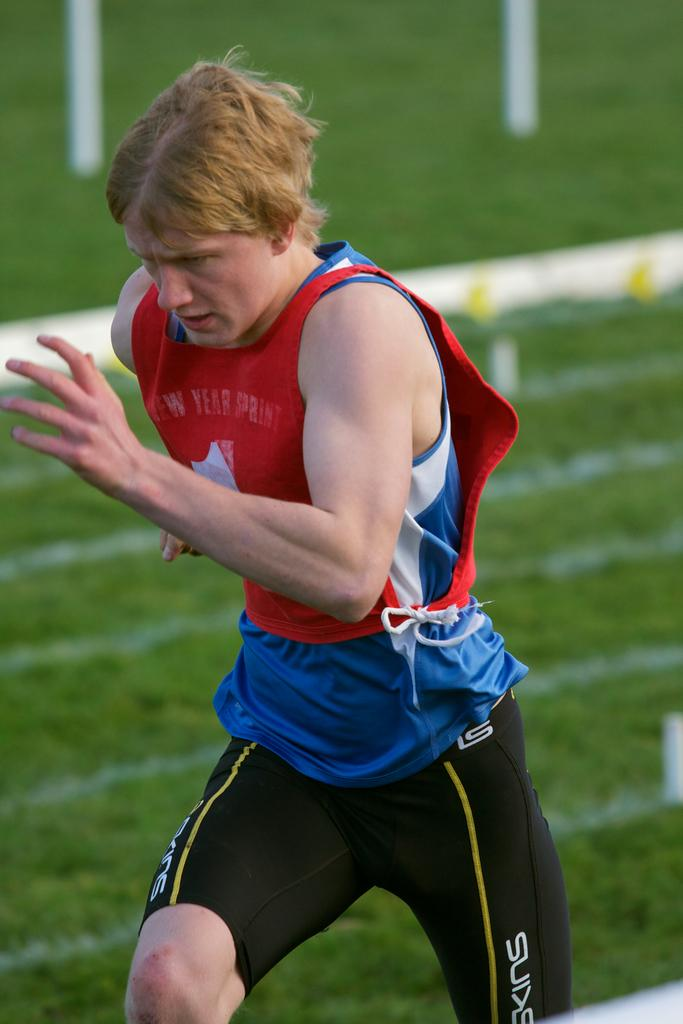<image>
Give a short and clear explanation of the subsequent image. A man running,  the word Skins is visible on his shorts. 